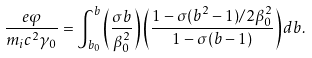Convert formula to latex. <formula><loc_0><loc_0><loc_500><loc_500>\frac { e \varphi } { m _ { i } c ^ { 2 } \gamma _ { 0 } } = \int _ { b _ { 0 } } ^ { b } \left ( \frac { \sigma b } { \beta _ { 0 } ^ { 2 } } \right ) \left ( \frac { 1 - \sigma ( b ^ { 2 } - 1 ) / 2 \beta _ { 0 } ^ { 2 } } { 1 - \sigma ( b - 1 ) } \right ) d b .</formula> 